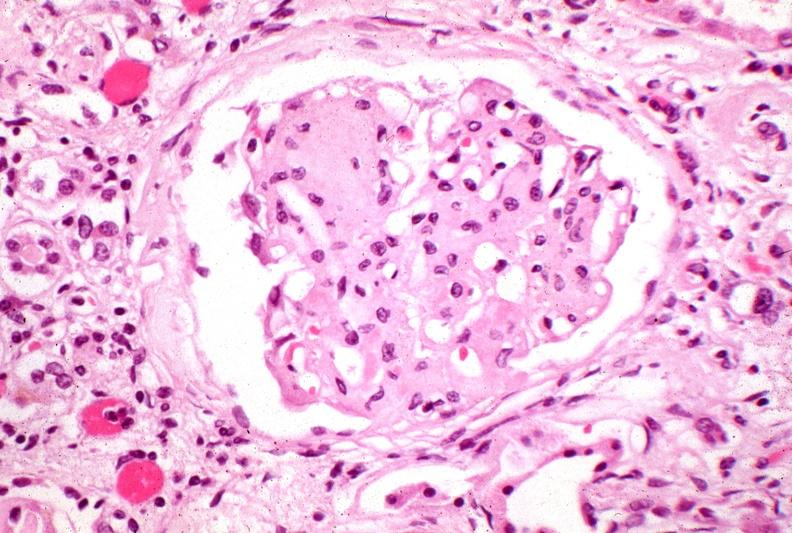where is this?
Answer the question using a single word or phrase. Urinary 